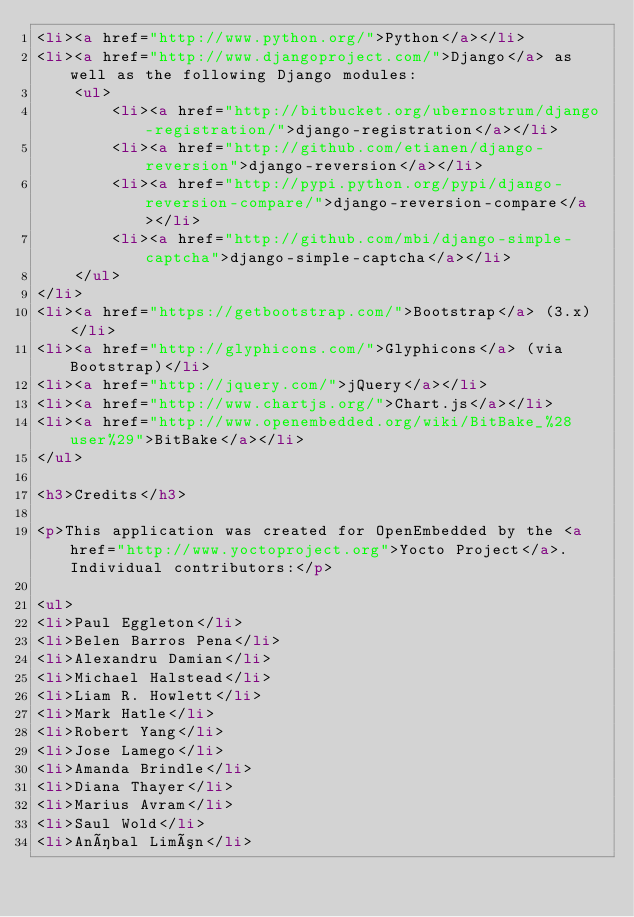Convert code to text. <code><loc_0><loc_0><loc_500><loc_500><_HTML_><li><a href="http://www.python.org/">Python</a></li>
<li><a href="http://www.djangoproject.com/">Django</a> as well as the following Django modules:
    <ul>
        <li><a href="http://bitbucket.org/ubernostrum/django-registration/">django-registration</a></li>
        <li><a href="http://github.com/etianen/django-reversion">django-reversion</a></li>
        <li><a href="http://pypi.python.org/pypi/django-reversion-compare/">django-reversion-compare</a></li>
        <li><a href="http://github.com/mbi/django-simple-captcha">django-simple-captcha</a></li>
    </ul>
</li>
<li><a href="https://getbootstrap.com/">Bootstrap</a> (3.x)</li>
<li><a href="http://glyphicons.com/">Glyphicons</a> (via Bootstrap)</li>
<li><a href="http://jquery.com/">jQuery</a></li>
<li><a href="http://www.chartjs.org/">Chart.js</a></li>
<li><a href="http://www.openembedded.org/wiki/BitBake_%28user%29">BitBake</a></li>
</ul>

<h3>Credits</h3>

<p>This application was created for OpenEmbedded by the <a href="http://www.yoctoproject.org">Yocto Project</a>. Individual contributors:</p>

<ul>
<li>Paul Eggleton</li>
<li>Belen Barros Pena</li>
<li>Alexandru Damian</li>
<li>Michael Halstead</li>
<li>Liam R. Howlett</li>
<li>Mark Hatle</li>
<li>Robert Yang</li>
<li>Jose Lamego</li>
<li>Amanda Brindle</li>
<li>Diana Thayer</li>
<li>Marius Avram</li>
<li>Saul Wold</li>
<li>Aníbal Limón</li></code> 